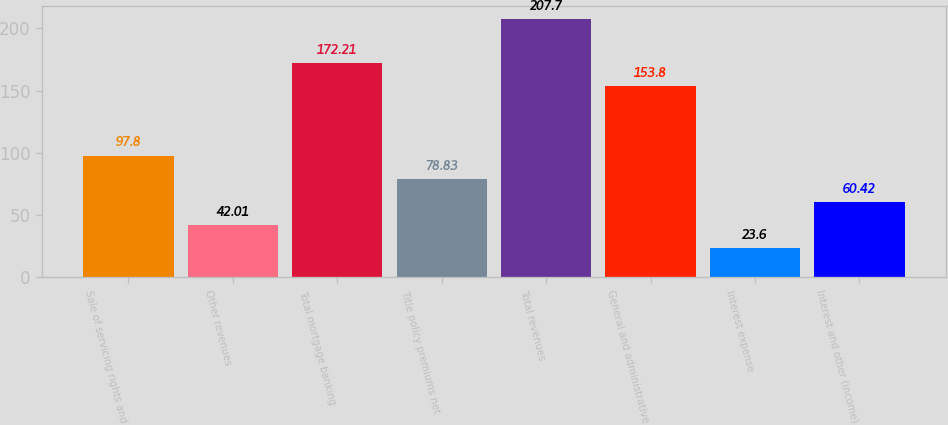<chart> <loc_0><loc_0><loc_500><loc_500><bar_chart><fcel>Sale of servicing rights and<fcel>Other revenues<fcel>Total mortgage banking<fcel>Title policy premiums net<fcel>Total revenues<fcel>General and administrative<fcel>Interest expense<fcel>Interest and other (income)<nl><fcel>97.8<fcel>42.01<fcel>172.21<fcel>78.83<fcel>207.7<fcel>153.8<fcel>23.6<fcel>60.42<nl></chart> 